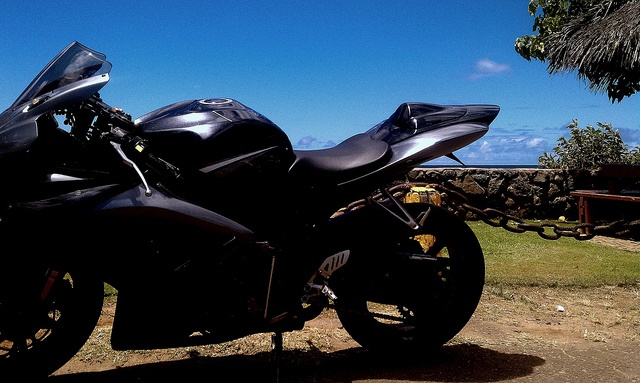Describe the objects in this image and their specific colors. I can see motorcycle in blue, black, gray, and navy tones, potted plant in blue, black, gray, lightblue, and darkgreen tones, and bench in blue, black, maroon, and gray tones in this image. 